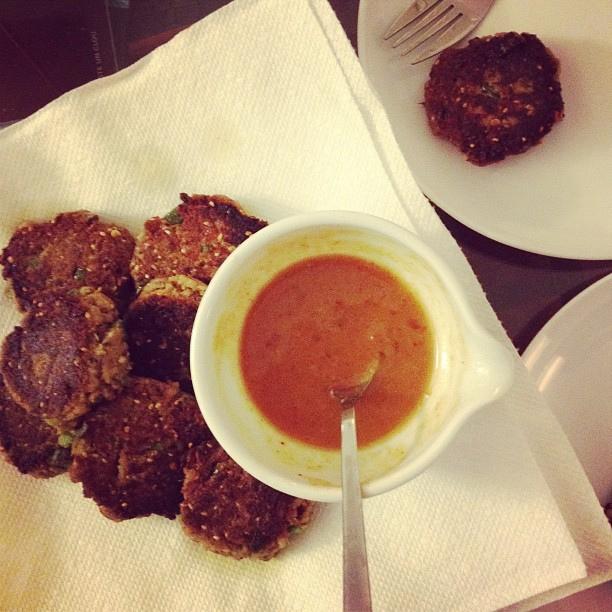Is there a spoon in this photo?
Answer briefly. Yes. How many tines are on the fork?
Concise answer only. 4. What is the yellow stuff in the bowl?
Answer briefly. Sauce. Where is the fork?
Short answer required. Plate. What liquid is in the cup?
Short answer required. Soup. 